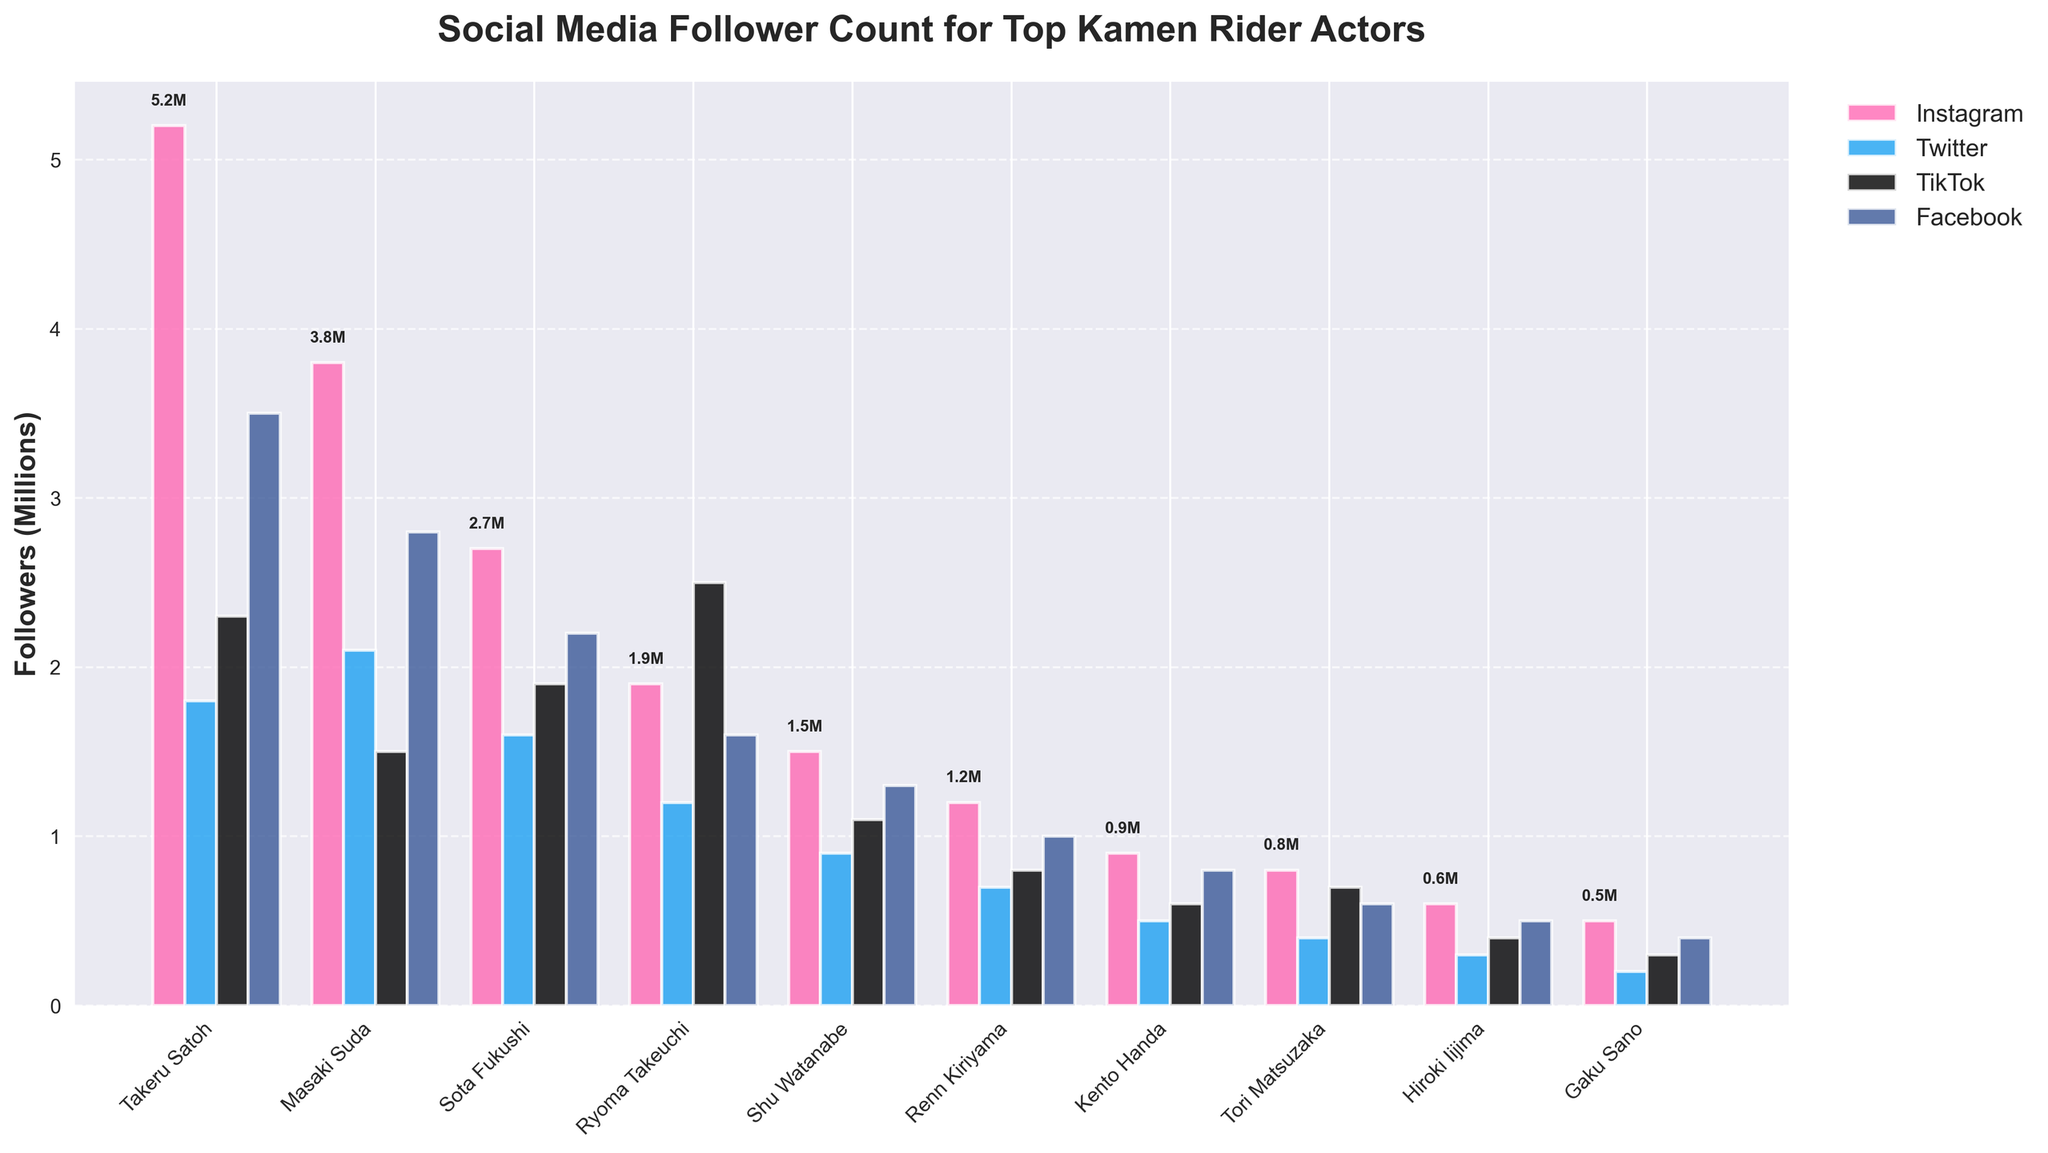Which actor has the highest number of followers on Instagram? Look for the tallest bar in the section for Instagram, which corresponds to Takeru Satoh.
Answer: Takeru Satoh Which platform does Ryoma Takeuchi have the most followers on? Compare the height of the bars representing Ryoma Takeuchi across all four platforms. TikTok has the tallest bar.
Answer: TikTok What is the total number of followers for Sota Fukushi across all platforms? Sum the follower counts of Sota Fukushi across Instagram, Twitter, TikTok, and Facebook: 2.7M + 1.6M + 1.9M + 2.2M = 8.4M (in millions).
Answer: 8.4M Who has fewer Instagram followers: Hiroki Iijima or Gaku Sano? Compare the height of the Instagram bars for both Hiroki Iijima and Gaku Sano. Hiroki Iijima has 0.6M and Gaku Sano has 0.5M, so Gaku Sano has fewer followers.
Answer: Gaku Sano Which actor has the least number of followers on Facebook? Look for the shortest bar in the Facebook section, which corresponds to Tori Matsuzaka with 0.6M followers.
Answer: Tori Matsuzaka For Takeru Satoh, which platform has the second-highest number of followers? Rank Takeru Satoh's follower counts on Instagram (5.2M), Twitter (1.8M), TikTok (2.3M), and Facebook (3.5M). The second-highest count is on Facebook.
Answer: Facebook Which two actors have more followers on TikTok than on Instagram? Compare the bars for TikTok and Instagram for each actor. Ryoma Takeuchi (2.5M TikTok > 1.9M Instagram) and Renn Kiriyama (0.8M TikTok > 0.7M Instagram) meet the criteria.
Answer: Ryoma Takeuchi, Renn Kiriyama What is the average number of followers for Masaki Suda on all platforms? Sum Masaki Suda's follower counts and then divide by the number of platforms: (3.8M + 2.1M + 1.5M + 2.8M) / 4 = 10.2M / 4 = 2.55M.
Answer: 2.55M Who has more total followers across all platforms: Shu Watanabe or Renn Kiriyama? Calculate the total followers for both actors: Shu Watanabe (1.5M + 0.9M + 1.1M + 1.3M = 4.8M) and Renn Kiriyama (1.2M + 0.7M + 0.8M + 1.0M = 3.7M). Shu Watanabe has more followers.
Answer: Shu Watanabe 